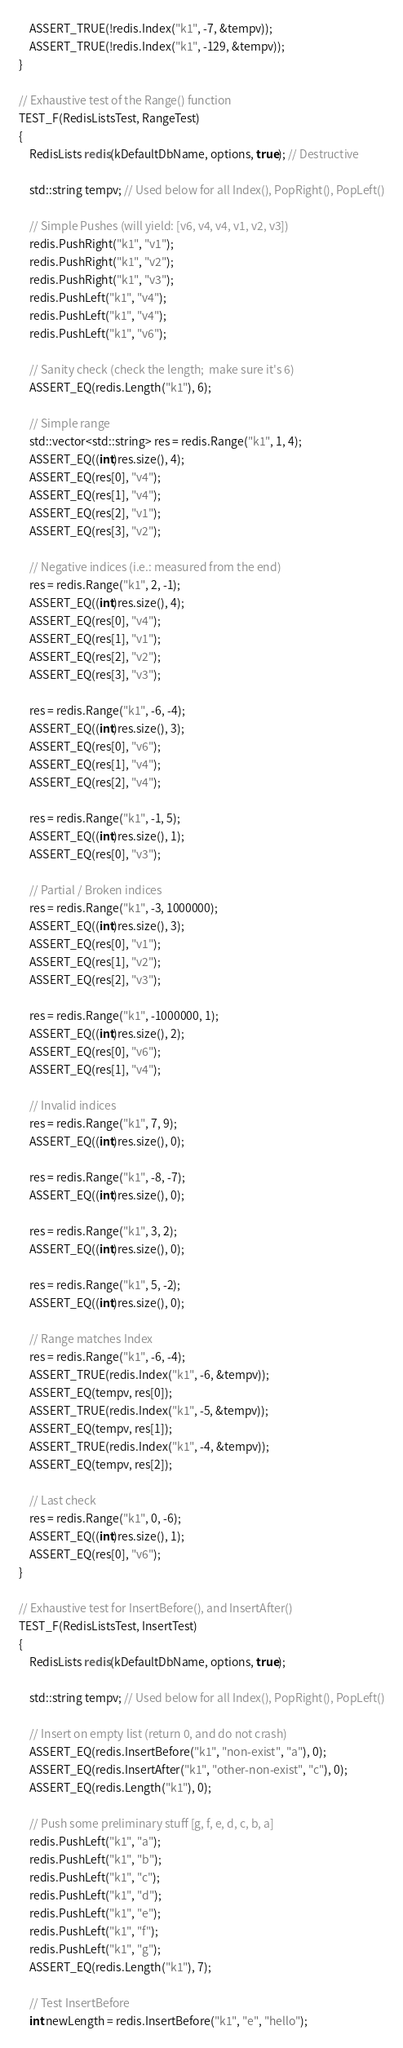Convert code to text. <code><loc_0><loc_0><loc_500><loc_500><_C++_>	ASSERT_TRUE(!redis.Index("k1", -7, &tempv));
	ASSERT_TRUE(!redis.Index("k1", -129, &tempv));
}

// Exhaustive test of the Range() function
TEST_F(RedisListsTest, RangeTest)
{
	RedisLists redis(kDefaultDbName, options, true); // Destructive

	std::string tempv; // Used below for all Index(), PopRight(), PopLeft()

	// Simple Pushes (will yield: [v6, v4, v4, v1, v2, v3])
	redis.PushRight("k1", "v1");
	redis.PushRight("k1", "v2");
	redis.PushRight("k1", "v3");
	redis.PushLeft("k1", "v4");
	redis.PushLeft("k1", "v4");
	redis.PushLeft("k1", "v6");

	// Sanity check (check the length;  make sure it's 6)
	ASSERT_EQ(redis.Length("k1"), 6);

	// Simple range
	std::vector<std::string> res = redis.Range("k1", 1, 4);
	ASSERT_EQ((int)res.size(), 4);
	ASSERT_EQ(res[0], "v4");
	ASSERT_EQ(res[1], "v4");
	ASSERT_EQ(res[2], "v1");
	ASSERT_EQ(res[3], "v2");

	// Negative indices (i.e.: measured from the end)
	res = redis.Range("k1", 2, -1);
	ASSERT_EQ((int)res.size(), 4);
	ASSERT_EQ(res[0], "v4");
	ASSERT_EQ(res[1], "v1");
	ASSERT_EQ(res[2], "v2");
	ASSERT_EQ(res[3], "v3");

	res = redis.Range("k1", -6, -4);
	ASSERT_EQ((int)res.size(), 3);
	ASSERT_EQ(res[0], "v6");
	ASSERT_EQ(res[1], "v4");
	ASSERT_EQ(res[2], "v4");

	res = redis.Range("k1", -1, 5);
	ASSERT_EQ((int)res.size(), 1);
	ASSERT_EQ(res[0], "v3");

	// Partial / Broken indices
	res = redis.Range("k1", -3, 1000000);
	ASSERT_EQ((int)res.size(), 3);
	ASSERT_EQ(res[0], "v1");
	ASSERT_EQ(res[1], "v2");
	ASSERT_EQ(res[2], "v3");

	res = redis.Range("k1", -1000000, 1);
	ASSERT_EQ((int)res.size(), 2);
	ASSERT_EQ(res[0], "v6");
	ASSERT_EQ(res[1], "v4");

	// Invalid indices
	res = redis.Range("k1", 7, 9);
	ASSERT_EQ((int)res.size(), 0);

	res = redis.Range("k1", -8, -7);
	ASSERT_EQ((int)res.size(), 0);

	res = redis.Range("k1", 3, 2);
	ASSERT_EQ((int)res.size(), 0);

	res = redis.Range("k1", 5, -2);
	ASSERT_EQ((int)res.size(), 0);

	// Range matches Index
	res = redis.Range("k1", -6, -4);
	ASSERT_TRUE(redis.Index("k1", -6, &tempv));
	ASSERT_EQ(tempv, res[0]);
	ASSERT_TRUE(redis.Index("k1", -5, &tempv));
	ASSERT_EQ(tempv, res[1]);
	ASSERT_TRUE(redis.Index("k1", -4, &tempv));
	ASSERT_EQ(tempv, res[2]);

	// Last check
	res = redis.Range("k1", 0, -6);
	ASSERT_EQ((int)res.size(), 1);
	ASSERT_EQ(res[0], "v6");
}

// Exhaustive test for InsertBefore(), and InsertAfter()
TEST_F(RedisListsTest, InsertTest)
{
	RedisLists redis(kDefaultDbName, options, true);

	std::string tempv; // Used below for all Index(), PopRight(), PopLeft()

	// Insert on empty list (return 0, and do not crash)
	ASSERT_EQ(redis.InsertBefore("k1", "non-exist", "a"), 0);
	ASSERT_EQ(redis.InsertAfter("k1", "other-non-exist", "c"), 0);
	ASSERT_EQ(redis.Length("k1"), 0);

	// Push some preliminary stuff [g, f, e, d, c, b, a]
	redis.PushLeft("k1", "a");
	redis.PushLeft("k1", "b");
	redis.PushLeft("k1", "c");
	redis.PushLeft("k1", "d");
	redis.PushLeft("k1", "e");
	redis.PushLeft("k1", "f");
	redis.PushLeft("k1", "g");
	ASSERT_EQ(redis.Length("k1"), 7);

	// Test InsertBefore
	int newLength = redis.InsertBefore("k1", "e", "hello");</code> 